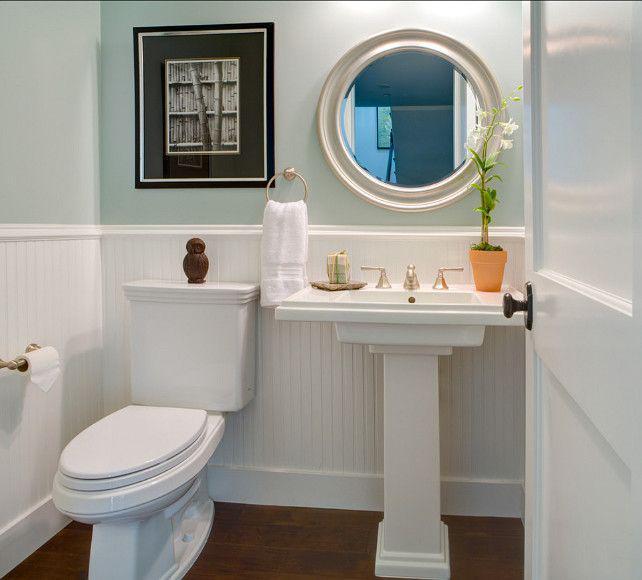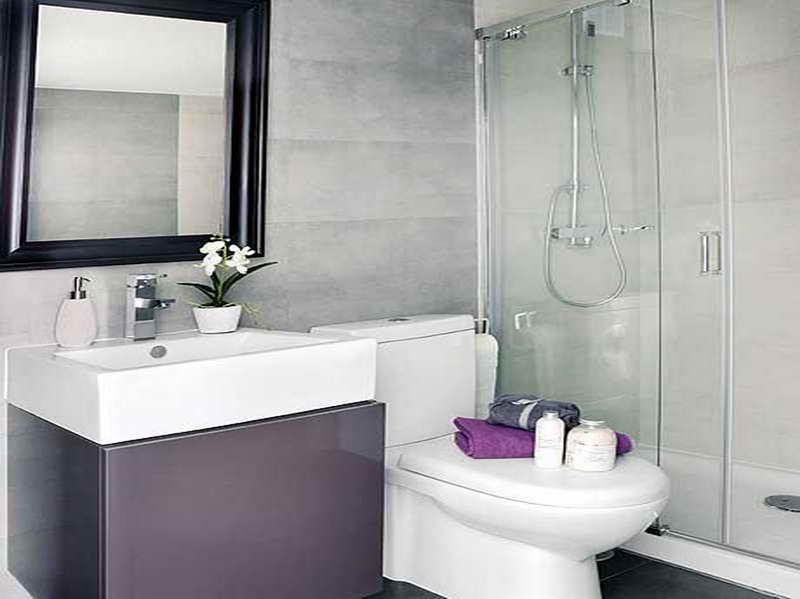The first image is the image on the left, the second image is the image on the right. Evaluate the accuracy of this statement regarding the images: "A bathroom features a toilet to the right of the sink.". Is it true? Answer yes or no. Yes. The first image is the image on the left, the second image is the image on the right. Given the left and right images, does the statement "There is a rectangular toilet in one of the images." hold true? Answer yes or no. No. 